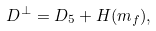Convert formula to latex. <formula><loc_0><loc_0><loc_500><loc_500>D ^ { \perp } = D _ { 5 } + H ( m _ { f } ) ,</formula> 